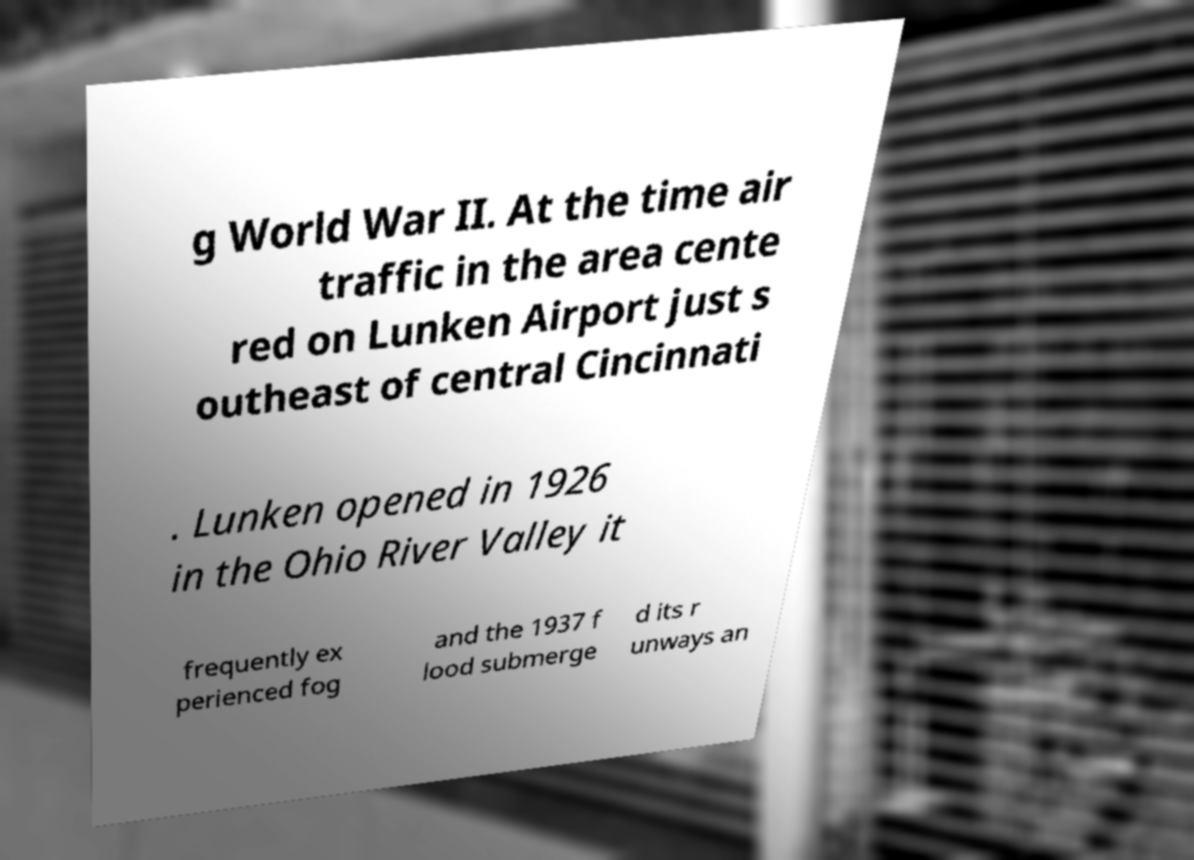Please read and relay the text visible in this image. What does it say? g World War II. At the time air traffic in the area cente red on Lunken Airport just s outheast of central Cincinnati . Lunken opened in 1926 in the Ohio River Valley it frequently ex perienced fog and the 1937 f lood submerge d its r unways an 